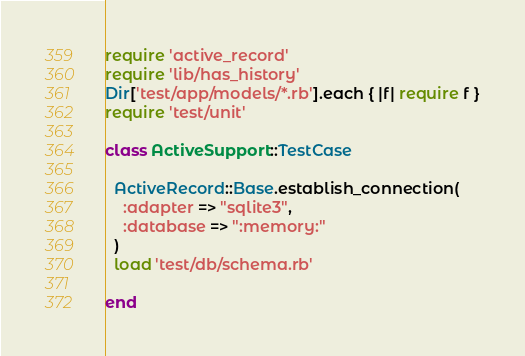Convert code to text. <code><loc_0><loc_0><loc_500><loc_500><_Ruby_>require 'active_record'
require 'lib/has_history'
Dir['test/app/models/*.rb'].each { |f| require f }
require 'test/unit'

class ActiveSupport::TestCase

  ActiveRecord::Base.establish_connection(
    :adapter => "sqlite3",
    :database => ":memory:"
  )
  load 'test/db/schema.rb'
  
end
</code> 